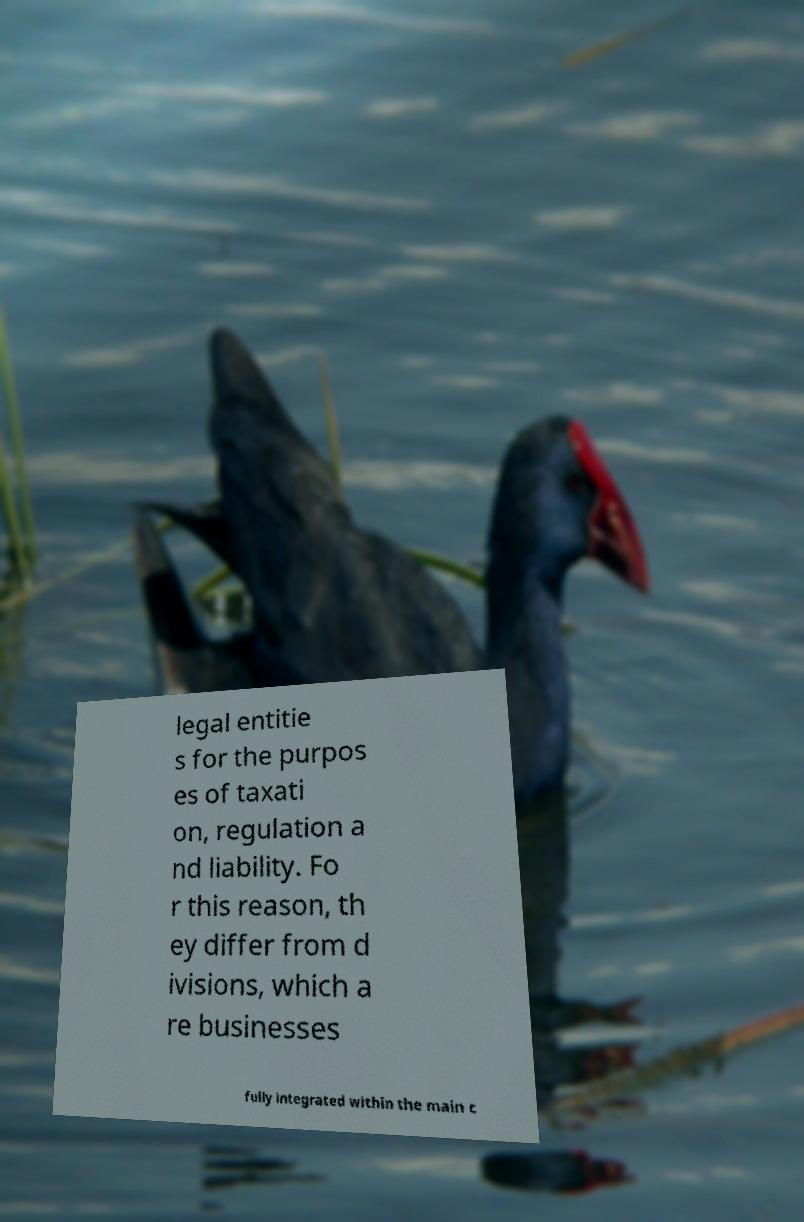There's text embedded in this image that I need extracted. Can you transcribe it verbatim? legal entitie s for the purpos es of taxati on, regulation a nd liability. Fo r this reason, th ey differ from d ivisions, which a re businesses fully integrated within the main c 